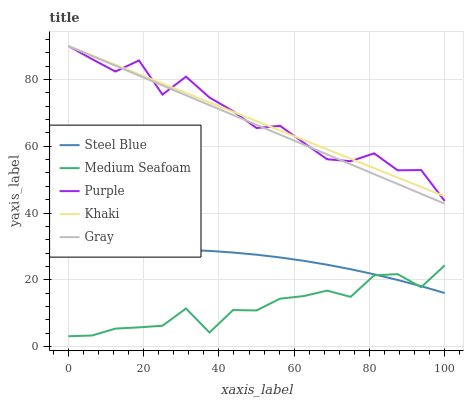Does Medium Seafoam have the minimum area under the curve?
Answer yes or no. Yes. Does Purple have the maximum area under the curve?
Answer yes or no. Yes. Does Gray have the minimum area under the curve?
Answer yes or no. No. Does Gray have the maximum area under the curve?
Answer yes or no. No. Is Gray the smoothest?
Answer yes or no. Yes. Is Purple the roughest?
Answer yes or no. Yes. Is Khaki the smoothest?
Answer yes or no. No. Is Khaki the roughest?
Answer yes or no. No. Does Gray have the lowest value?
Answer yes or no. No. Does Khaki have the highest value?
Answer yes or no. Yes. Does Steel Blue have the highest value?
Answer yes or no. No. Is Medium Seafoam less than Purple?
Answer yes or no. Yes. Is Gray greater than Medium Seafoam?
Answer yes or no. Yes. Does Gray intersect Purple?
Answer yes or no. Yes. Is Gray less than Purple?
Answer yes or no. No. Is Gray greater than Purple?
Answer yes or no. No. Does Medium Seafoam intersect Purple?
Answer yes or no. No. 